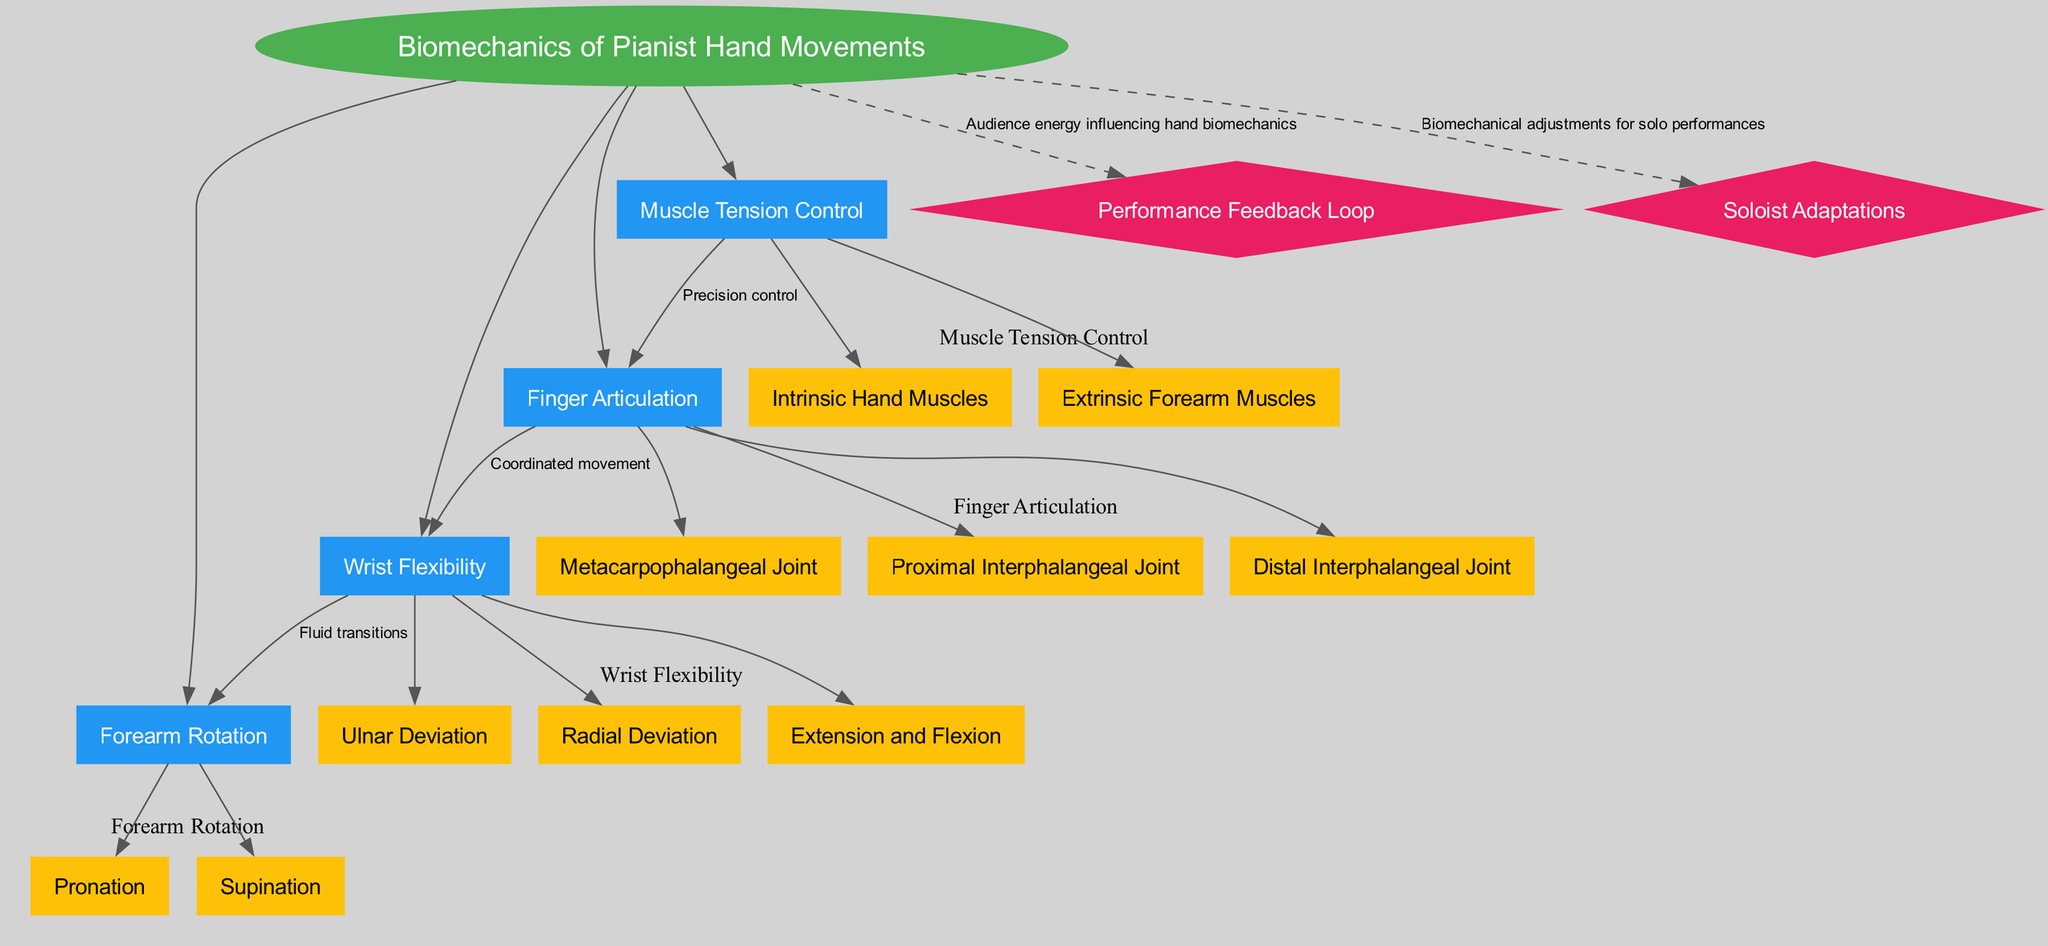What is the central concept of the diagram? The diagram identifies "Biomechanics of Pianist Hand Movements" as the central concept, which is highlighted in an ellipse at the top of the diagram.
Answer: Biomechanics of Pianist Hand Movements How many main elements are directly connected to the central concept? There are four main elements listed under the central concept, as indicated by the four separate rectangular nodes directly linked to the central ellipse.
Answer: 4 Which element connects Finger Articulation to Wrist Flexibility? The diagram explicitly defines the relationship with the label "Coordinated movement," indicating how Finger Articulation influences Wrist Flexibility.
Answer: Coordinated movement What are the three sub-elements of Finger Articulation? The diagram details three sub-elements beneath Finger Articulation: Metacarpophalangeal Joint, Proximal Interphalangeal Joint, and Distal Interphalangeal Joint, specifically marked under the corresponding section.
Answer: Metacarpophalangeal Joint, Proximal Interphalangeal Joint, Distal Interphalangeal Joint How does Muscle Tension Control relate to Finger Articulation? The connection is defined by the label "Precision control," indicating that Muscle Tension Control affects the movements involved in Finger Articulation, enhancing precision during performance.
Answer: Precision control Which two main elements are connected through Fluid transitions? The connection label "Fluid transitions" helps identify that Wrist Flexibility and Forearm Rotation are linked, indicating how flexibility impacts rotational movement.
Answer: Wrist Flexibility, Forearm Rotation What is the performance feedback loop's role in the diagram? The diagram indicates that the Performance Feedback Loop influences hand biomechanics, signifying that audience energy has a direct impact on the pianist’s movements and techniques during a performance.
Answer: Audience energy influencing hand biomechanics What adaptations might a pianist make as a soloist according to the diagram? The Soloist Adaptations element suggests that there are specific biomechanical adjustments that a pianist employs during solo performances, emphasizing individual techniques for rendering pieces effectively.
Answer: Biomechanical adjustments for solo performances 